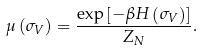<formula> <loc_0><loc_0><loc_500><loc_500>\mu \left ( \sigma _ { V } \right ) = \frac { \exp \left [ - \beta H \left ( \sigma _ { V } \right ) \right ] } { Z _ { N } } .</formula> 